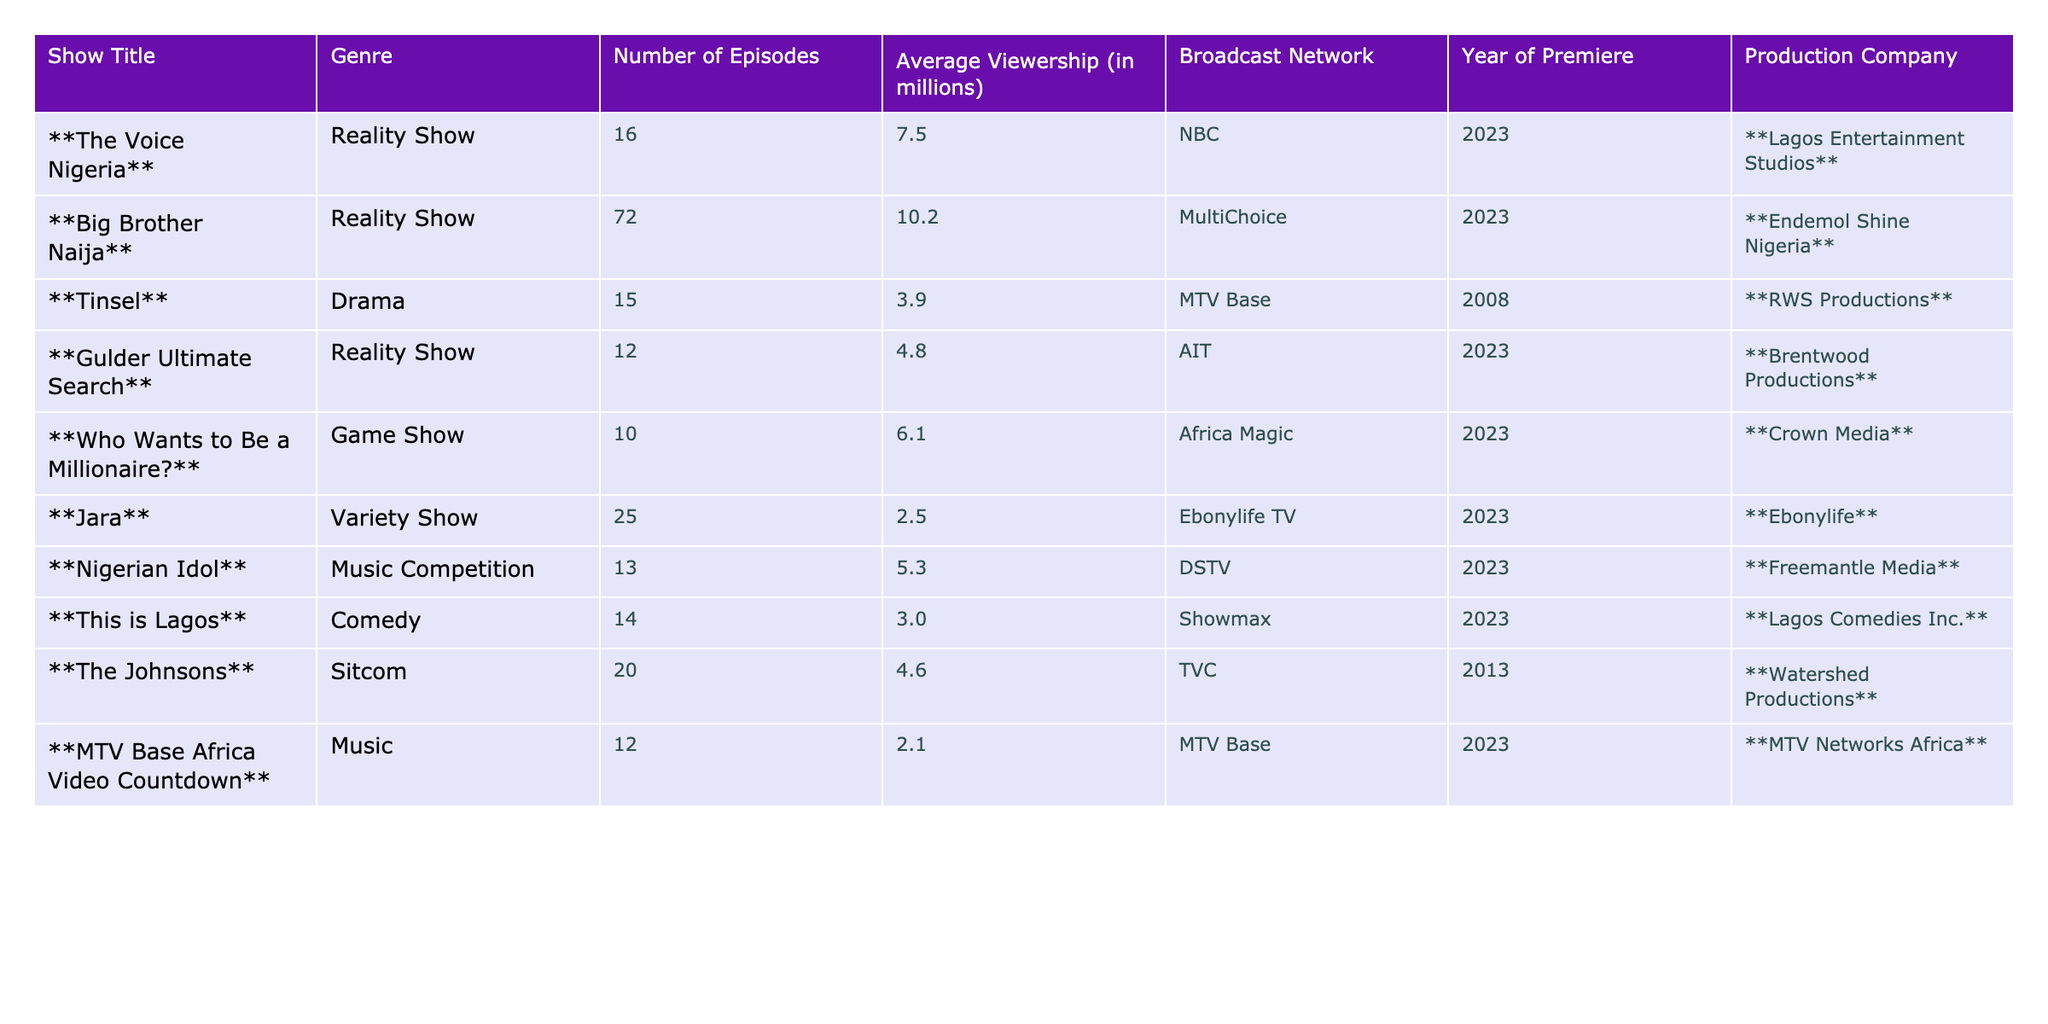What is the title of the reality show with the highest average viewership? The table lists the average viewership for each show. By checking the "Average Viewership" column, we find that "Big Brother Naija" has the highest value at 10.2 million viewers.
Answer: Big Brother Naija How many episodes does "Nigerian Idol" have? The table shows that "Nigerian Idol" has 13 episodes listed under the "Number of Episodes" column.
Answer: 13 What is the average viewership of all reality shows on the table? First, we identify the reality shows: "The Voice Nigeria," "Big Brother Naija," "Gulder Ultimate Search," and calculate their average viewership: (7.5 + 10.2 + 4.8) / 3 = 7.5 million.
Answer: 7.5 million Which genre has the lowest average viewership based on the table data? We compare the average viewership across genres: Reality Show (7.5, 10.2, 4.8), Drama (3.9), Game Show (6.1), Variety Show (2.5), Music Competition (5.3), Comedy (3.0), Sitcom (4.6), and Music (2.1). The lowest average is for the Music genre at 2.1 million.
Answer: Music Is "Tinsel" a game show? In the table, "Tinsel" is labeled under the Drama genre, which indicates it is not a game show.
Answer: No What is the total number of episodes for all the shows combined? We sum up the episodes of all shows listed: 16 + 72 + 15 + 12 + 10 + 25 + 13 + 14 + 20 + 12 = 299.
Answer: 299 Which broadcast network has the highest average viewership from its shows? Checking the average viewership for each network: NBC (7.5), MultiChoice (10.2), AIT (4.8), Africa Magic (6.1), Ebonylife TV (2.5), DSTV (5.3), MTV Base (2.1). MultiChoice has the highest average viewership with 10.2 million.
Answer: MultiChoice What is the difference in average viewership between the top-rated reality show and the lowest-rated music show? The highest-rated reality show, "Big Brother Naija," has 10.2 million viewers, while the lowest-rated music show, "MTV Base Africa Video Countdown," has 2.1 million viewers. The difference is 10.2 - 2.1 = 8.1 million.
Answer: 8.1 million Is "The Johnsons" a comedy show? The table categorizes "The Johnsons" under the Sitcom genre, which is a type of comedy, making this statement true.
Answer: Yes List all the production companies for variety or music shows in the table. Both genres include "Jara" and "MTV Base Africa Video Countdown." The respective production companies are Ebonylife and MTV Networks Africa.
Answer: Ebonylife, MTV Networks Africa 